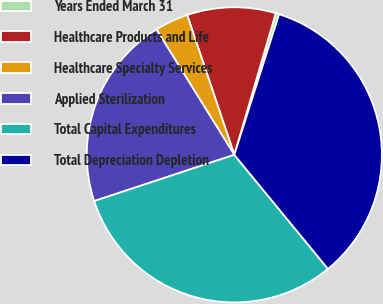Convert chart to OTSL. <chart><loc_0><loc_0><loc_500><loc_500><pie_chart><fcel>Years Ended March 31<fcel>Healthcare Products and Life<fcel>Healthcare Specialty Services<fcel>Applied Sterilization<fcel>Total Capital Expenditures<fcel>Total Depreciation Depletion<nl><fcel>0.38%<fcel>9.71%<fcel>3.67%<fcel>21.23%<fcel>30.87%<fcel>34.15%<nl></chart> 